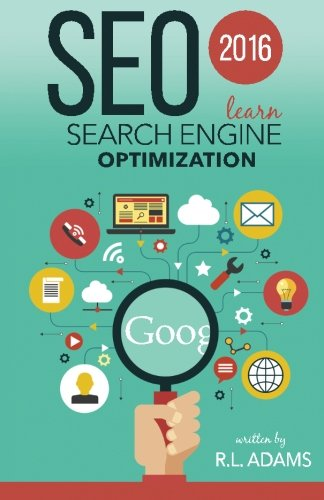What is the genre of this book? The genre of this book is Computers & Technology. It specifically pertains to digital marketing and SEO, making it a valuable resource for professionals and enthusiasts in the tech industry. 